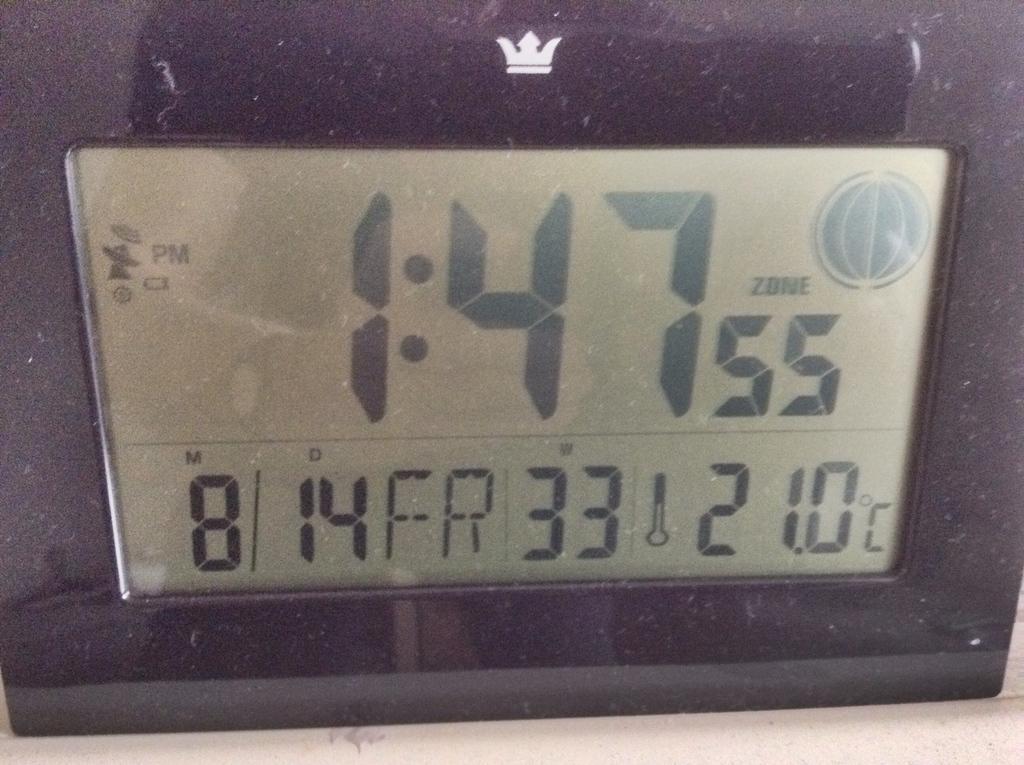How would you summarize this image in a sentence or two? This picture is consists of speedometer in the image. 